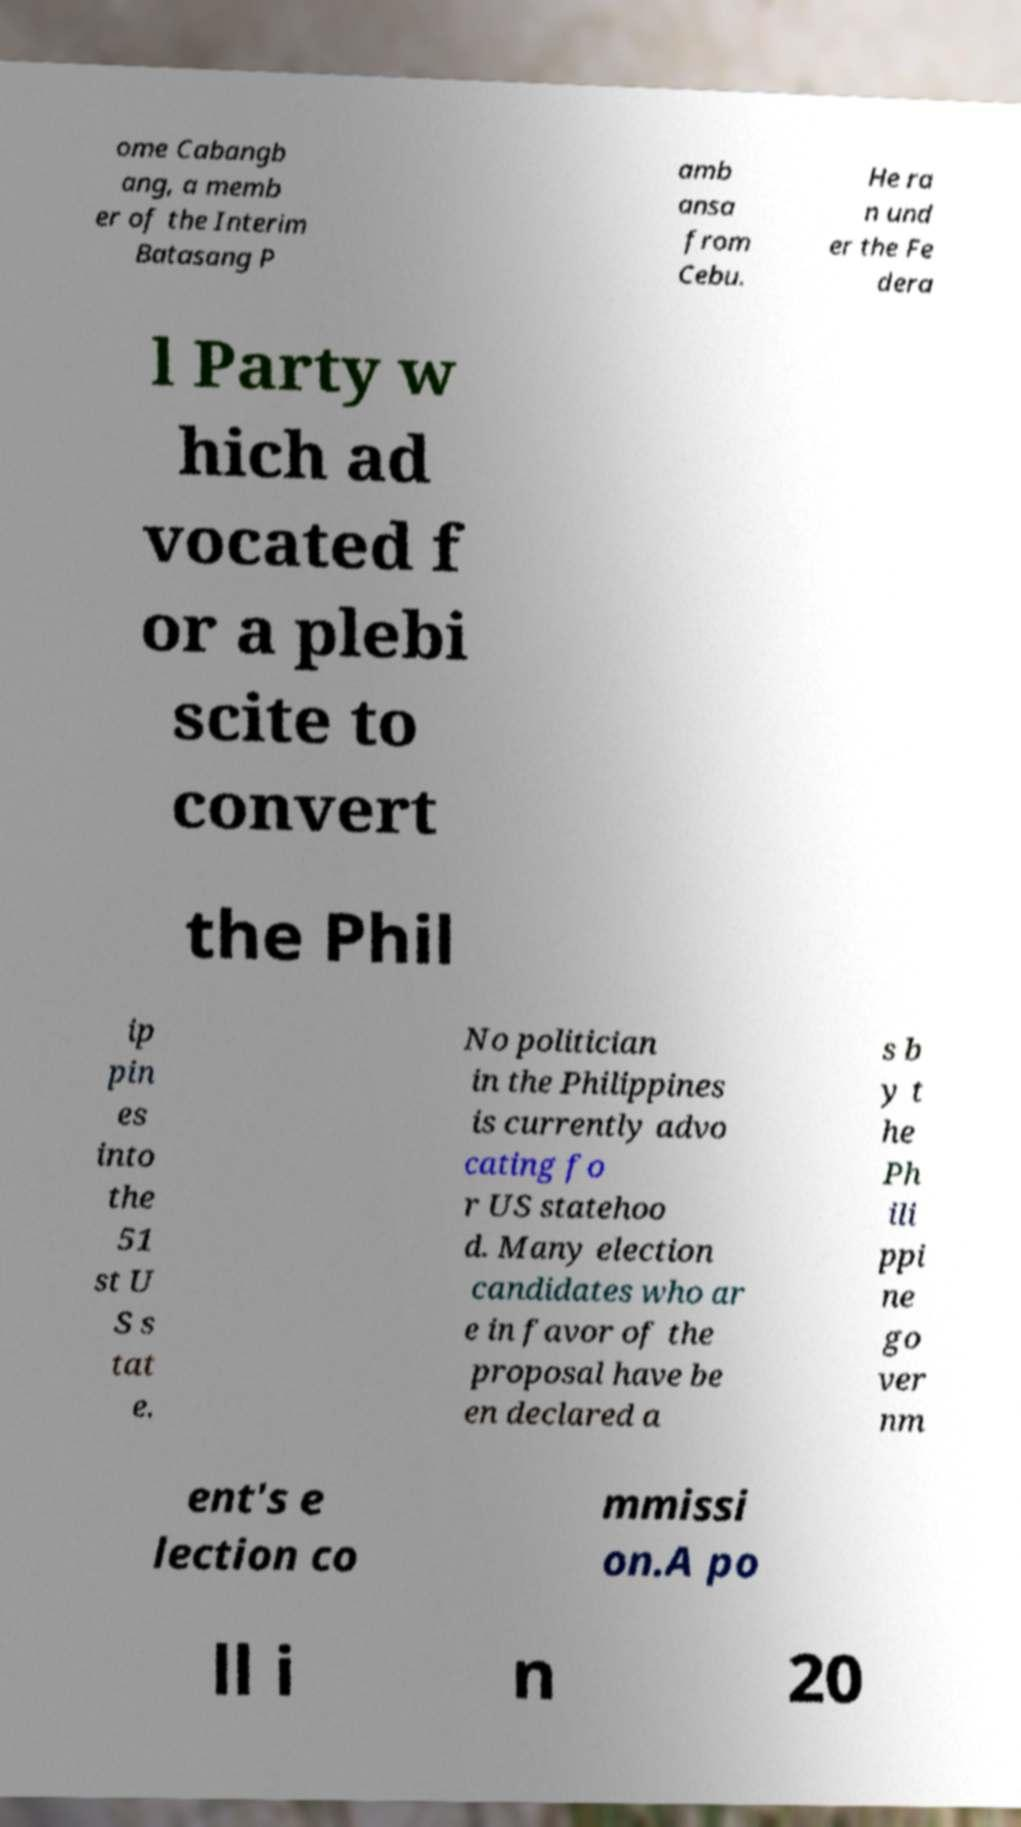Please identify and transcribe the text found in this image. ome Cabangb ang, a memb er of the Interim Batasang P amb ansa from Cebu. He ra n und er the Fe dera l Party w hich ad vocated f or a plebi scite to convert the Phil ip pin es into the 51 st U S s tat e. No politician in the Philippines is currently advo cating fo r US statehoo d. Many election candidates who ar e in favor of the proposal have be en declared a s b y t he Ph ili ppi ne go ver nm ent's e lection co mmissi on.A po ll i n 20 